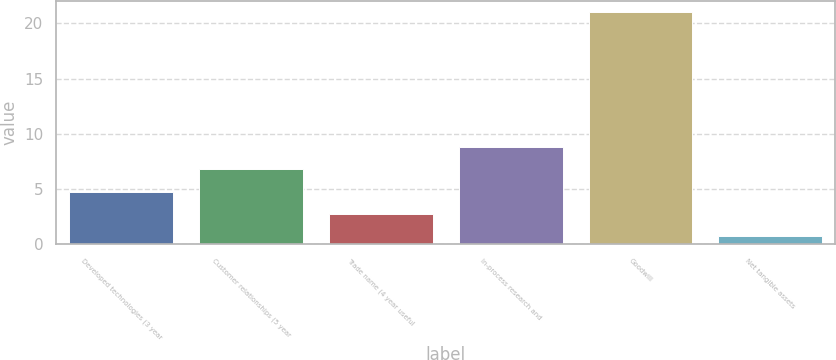Convert chart. <chart><loc_0><loc_0><loc_500><loc_500><bar_chart><fcel>Developed technologies (3 year<fcel>Customer relationships (5 year<fcel>Trade name (4 year useful<fcel>In-process research and<fcel>Goodwill<fcel>Net tangible assets<nl><fcel>4.76<fcel>6.79<fcel>2.73<fcel>8.82<fcel>21<fcel>0.7<nl></chart> 